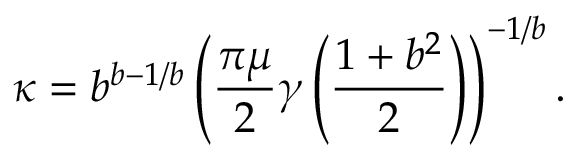<formula> <loc_0><loc_0><loc_500><loc_500>\kappa = b ^ { b - 1 / b } \left ( \frac { \pi \mu } { 2 } \gamma \left ( \frac { 1 + b ^ { 2 } } { 2 } \right ) \right ) ^ { - 1 / b } .</formula> 